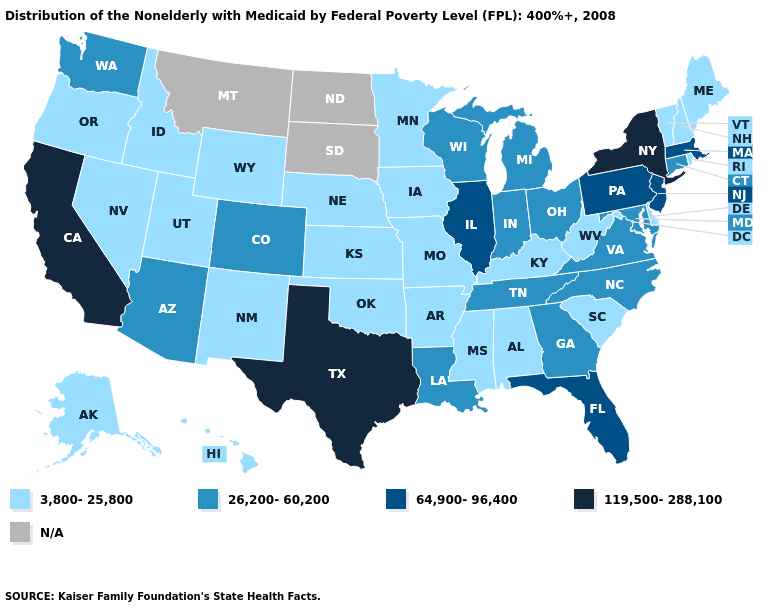Name the states that have a value in the range N/A?
Short answer required. Montana, North Dakota, South Dakota. What is the value of Idaho?
Be succinct. 3,800-25,800. What is the highest value in the MidWest ?
Answer briefly. 64,900-96,400. What is the highest value in the USA?
Write a very short answer. 119,500-288,100. Does the first symbol in the legend represent the smallest category?
Write a very short answer. Yes. Does California have the lowest value in the USA?
Give a very brief answer. No. Which states have the highest value in the USA?
Give a very brief answer. California, New York, Texas. What is the value of Oregon?
Quick response, please. 3,800-25,800. What is the lowest value in states that border New Hampshire?
Concise answer only. 3,800-25,800. Does New York have the lowest value in the Northeast?
Concise answer only. No. Name the states that have a value in the range 64,900-96,400?
Be succinct. Florida, Illinois, Massachusetts, New Jersey, Pennsylvania. What is the value of Kentucky?
Short answer required. 3,800-25,800. 